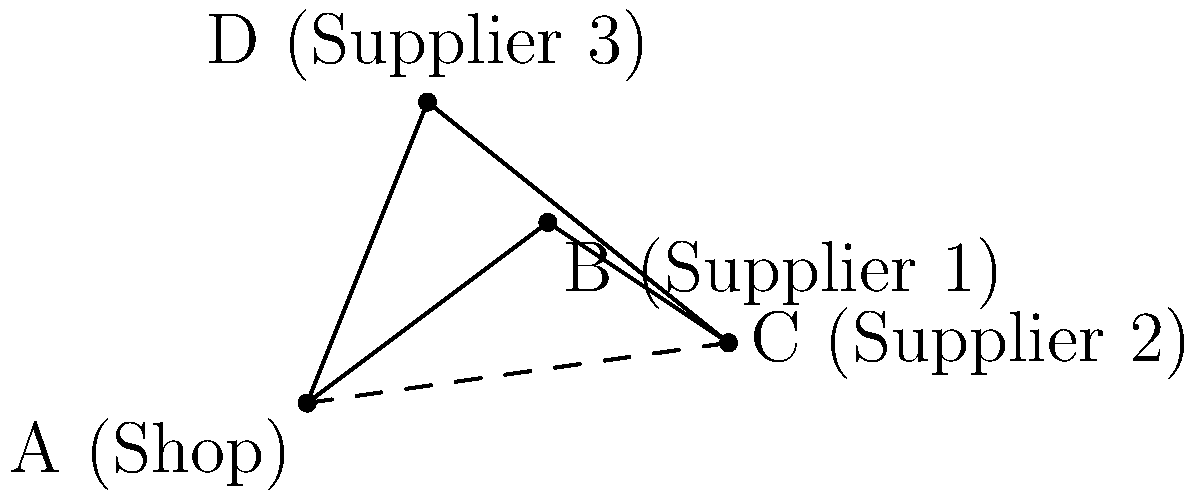As a small business owner, you need to visit three suppliers to collect inventory for your shop. The locations are represented on a map using vectors, where your shop is at point A(0,0), Supplier 1 is at B(4,3), Supplier 2 is at C(7,1), and Supplier 3 is at D(2,5). To save time and fuel, you want to determine the most efficient route. If you start at your shop (A), visit all suppliers once, and return to your shop, what is the total distance traveled if you choose the shortest possible route? To solve this problem, we'll follow these steps:

1) First, we need to calculate the distances between all points:
   AB = $\sqrt{4^2 + 3^2} = 5$
   BC = $\sqrt{3^2 + 2^2} = \sqrt{13}$
   CD = $\sqrt{5^2 + 4^2} = \sqrt{41}$
   DA = $\sqrt{2^2 + 5^2} = \sqrt{29}$
   AC = $\sqrt{7^2 + 1^2} = \sqrt{50}$

2) The problem is equivalent to finding the shortest Hamiltonian cycle, which is known as the Traveling Salesman Problem. For a small number of points, we can check all possible routes:

   ABCDA: 5 + $\sqrt{13}$ + $\sqrt{41}$ + $\sqrt{29}$ ≈ 18.69
   ABDCA: 5 + $\sqrt{29}$ + $\sqrt{41}$ + $\sqrt{50}$ ≈ 20.72
   ACBDA: $\sqrt{50}$ + $\sqrt{13}$ + $\sqrt{29}$ + 5 ≈ 18.55
   ACDBA: $\sqrt{50}$ + $\sqrt{41}$ + $\sqrt{29}$ + 5 ≈ 21.15
   ADBCA: $\sqrt{29}$ + $\sqrt{41}$ + $\sqrt{13}$ + 5 ≈ 19.60
   ADCBA: $\sqrt{29}$ + $\sqrt{41}$ + $\sqrt{13}$ + 5 ≈ 19.60

3) The shortest route is ACBDA with a total distance of approximately 18.55 units.
Answer: 18.55 units 